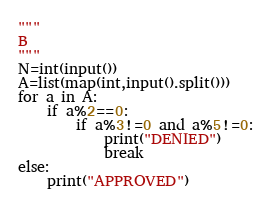<code> <loc_0><loc_0><loc_500><loc_500><_Python_>"""
B
"""
N=int(input())
A=list(map(int,input().split()))
for a in A:
    if a%2==0:
        if a%3!=0 and a%5!=0:
            print("DENIED")
            break
else:
    print("APPROVED")</code> 